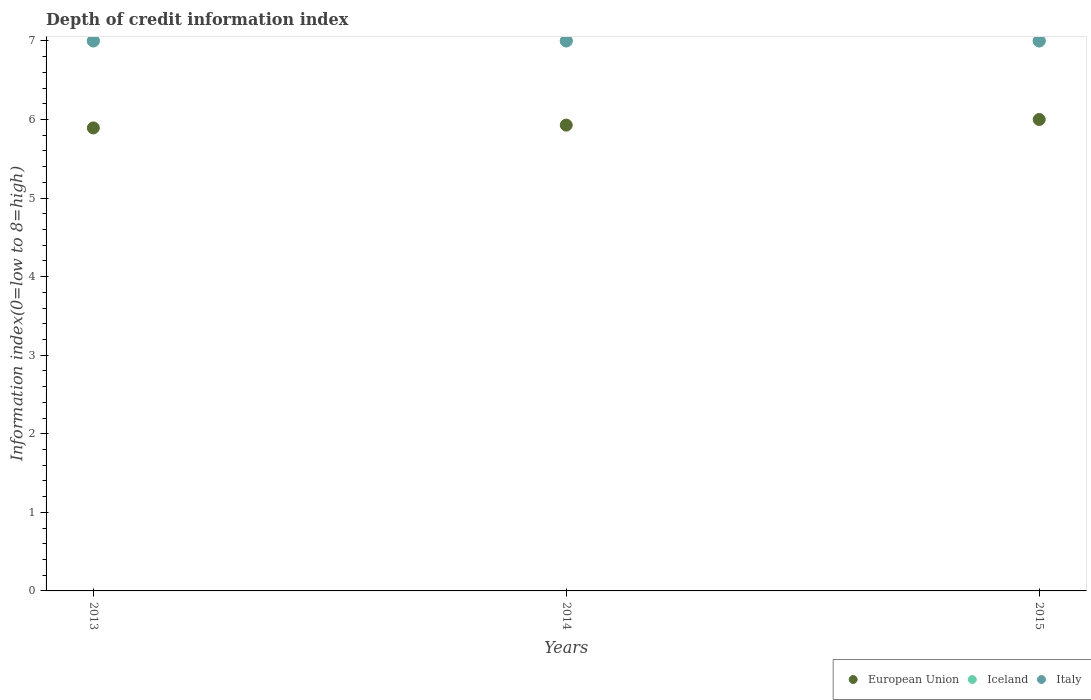Is the number of dotlines equal to the number of legend labels?
Give a very brief answer. Yes. What is the information index in European Union in 2014?
Offer a very short reply. 5.93. Across all years, what is the maximum information index in Iceland?
Provide a short and direct response. 7. Across all years, what is the minimum information index in European Union?
Your answer should be very brief. 5.89. In which year was the information index in European Union maximum?
Offer a terse response. 2015. In which year was the information index in Italy minimum?
Provide a succinct answer. 2013. What is the total information index in European Union in the graph?
Provide a short and direct response. 17.82. What is the difference between the information index in European Union in 2013 and that in 2014?
Offer a very short reply. -0.04. What is the average information index in Iceland per year?
Keep it short and to the point. 7. In the year 2013, what is the difference between the information index in European Union and information index in Iceland?
Make the answer very short. -1.11. In how many years, is the information index in Italy greater than 0.4?
Your response must be concise. 3. What is the ratio of the information index in European Union in 2013 to that in 2015?
Make the answer very short. 0.98. What is the difference between the highest and the second highest information index in Iceland?
Ensure brevity in your answer.  0. What is the difference between the highest and the lowest information index in Italy?
Keep it short and to the point. 0. In how many years, is the information index in European Union greater than the average information index in European Union taken over all years?
Offer a very short reply. 1. Is it the case that in every year, the sum of the information index in European Union and information index in Italy  is greater than the information index in Iceland?
Provide a succinct answer. Yes. Does the information index in European Union monotonically increase over the years?
Provide a succinct answer. Yes. Is the information index in Italy strictly greater than the information index in Iceland over the years?
Provide a succinct answer. No. Does the graph contain grids?
Keep it short and to the point. No. Where does the legend appear in the graph?
Ensure brevity in your answer.  Bottom right. How many legend labels are there?
Provide a short and direct response. 3. How are the legend labels stacked?
Provide a short and direct response. Horizontal. What is the title of the graph?
Keep it short and to the point. Depth of credit information index. What is the label or title of the X-axis?
Ensure brevity in your answer.  Years. What is the label or title of the Y-axis?
Offer a terse response. Information index(0=low to 8=high). What is the Information index(0=low to 8=high) of European Union in 2013?
Ensure brevity in your answer.  5.89. What is the Information index(0=low to 8=high) of Italy in 2013?
Keep it short and to the point. 7. What is the Information index(0=low to 8=high) of European Union in 2014?
Give a very brief answer. 5.93. What is the Information index(0=low to 8=high) of Iceland in 2014?
Provide a short and direct response. 7. What is the Information index(0=low to 8=high) in Italy in 2014?
Offer a very short reply. 7. What is the Information index(0=low to 8=high) of European Union in 2015?
Provide a short and direct response. 6. Across all years, what is the maximum Information index(0=low to 8=high) in European Union?
Your answer should be very brief. 6. Across all years, what is the maximum Information index(0=low to 8=high) of Iceland?
Offer a very short reply. 7. Across all years, what is the minimum Information index(0=low to 8=high) in European Union?
Offer a very short reply. 5.89. Across all years, what is the minimum Information index(0=low to 8=high) in Iceland?
Ensure brevity in your answer.  7. Across all years, what is the minimum Information index(0=low to 8=high) of Italy?
Ensure brevity in your answer.  7. What is the total Information index(0=low to 8=high) in European Union in the graph?
Keep it short and to the point. 17.82. What is the difference between the Information index(0=low to 8=high) in European Union in 2013 and that in 2014?
Provide a succinct answer. -0.04. What is the difference between the Information index(0=low to 8=high) in Iceland in 2013 and that in 2014?
Offer a terse response. 0. What is the difference between the Information index(0=low to 8=high) of European Union in 2013 and that in 2015?
Offer a terse response. -0.11. What is the difference between the Information index(0=low to 8=high) of European Union in 2014 and that in 2015?
Make the answer very short. -0.07. What is the difference between the Information index(0=low to 8=high) in Iceland in 2014 and that in 2015?
Your response must be concise. 0. What is the difference between the Information index(0=low to 8=high) in European Union in 2013 and the Information index(0=low to 8=high) in Iceland in 2014?
Your answer should be very brief. -1.11. What is the difference between the Information index(0=low to 8=high) in European Union in 2013 and the Information index(0=low to 8=high) in Italy in 2014?
Your answer should be compact. -1.11. What is the difference between the Information index(0=low to 8=high) in Iceland in 2013 and the Information index(0=low to 8=high) in Italy in 2014?
Keep it short and to the point. 0. What is the difference between the Information index(0=low to 8=high) in European Union in 2013 and the Information index(0=low to 8=high) in Iceland in 2015?
Provide a short and direct response. -1.11. What is the difference between the Information index(0=low to 8=high) in European Union in 2013 and the Information index(0=low to 8=high) in Italy in 2015?
Ensure brevity in your answer.  -1.11. What is the difference between the Information index(0=low to 8=high) of European Union in 2014 and the Information index(0=low to 8=high) of Iceland in 2015?
Ensure brevity in your answer.  -1.07. What is the difference between the Information index(0=low to 8=high) of European Union in 2014 and the Information index(0=low to 8=high) of Italy in 2015?
Keep it short and to the point. -1.07. What is the average Information index(0=low to 8=high) in European Union per year?
Ensure brevity in your answer.  5.94. In the year 2013, what is the difference between the Information index(0=low to 8=high) of European Union and Information index(0=low to 8=high) of Iceland?
Ensure brevity in your answer.  -1.11. In the year 2013, what is the difference between the Information index(0=low to 8=high) of European Union and Information index(0=low to 8=high) of Italy?
Give a very brief answer. -1.11. In the year 2014, what is the difference between the Information index(0=low to 8=high) of European Union and Information index(0=low to 8=high) of Iceland?
Your answer should be compact. -1.07. In the year 2014, what is the difference between the Information index(0=low to 8=high) of European Union and Information index(0=low to 8=high) of Italy?
Give a very brief answer. -1.07. In the year 2015, what is the difference between the Information index(0=low to 8=high) of European Union and Information index(0=low to 8=high) of Iceland?
Ensure brevity in your answer.  -1. What is the ratio of the Information index(0=low to 8=high) in European Union in 2013 to that in 2014?
Ensure brevity in your answer.  0.99. What is the ratio of the Information index(0=low to 8=high) of Iceland in 2013 to that in 2014?
Your answer should be compact. 1. What is the ratio of the Information index(0=low to 8=high) of European Union in 2013 to that in 2015?
Offer a terse response. 0.98. What is the ratio of the Information index(0=low to 8=high) in Italy in 2013 to that in 2015?
Your response must be concise. 1. What is the difference between the highest and the second highest Information index(0=low to 8=high) in European Union?
Keep it short and to the point. 0.07. What is the difference between the highest and the second highest Information index(0=low to 8=high) of Italy?
Make the answer very short. 0. What is the difference between the highest and the lowest Information index(0=low to 8=high) of European Union?
Your answer should be very brief. 0.11. What is the difference between the highest and the lowest Information index(0=low to 8=high) of Iceland?
Your response must be concise. 0. What is the difference between the highest and the lowest Information index(0=low to 8=high) in Italy?
Offer a terse response. 0. 